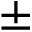<formula> <loc_0><loc_0><loc_500><loc_500>\pm</formula> 